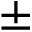<formula> <loc_0><loc_0><loc_500><loc_500>\pm</formula> 